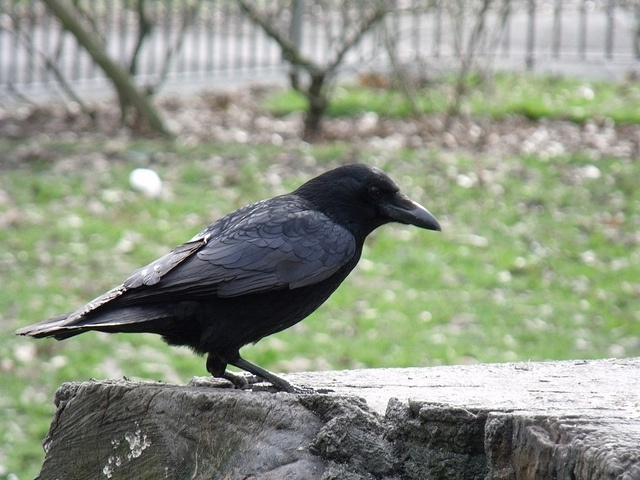Describe the objects in this image and their specific colors. I can see a bird in gray, black, and darkgray tones in this image. 